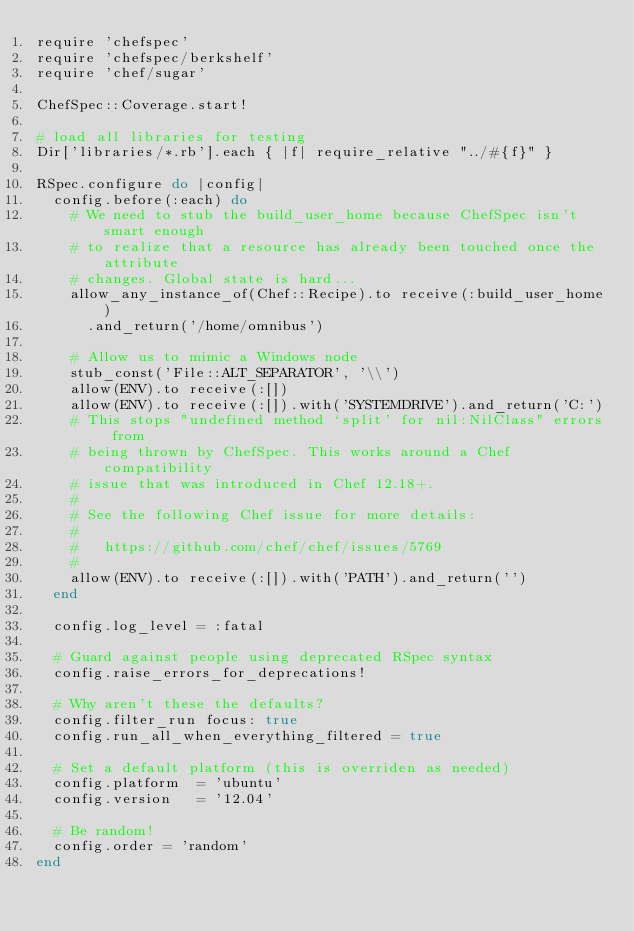Convert code to text. <code><loc_0><loc_0><loc_500><loc_500><_Ruby_>require 'chefspec'
require 'chefspec/berkshelf'
require 'chef/sugar'

ChefSpec::Coverage.start!

# load all libraries for testing
Dir['libraries/*.rb'].each { |f| require_relative "../#{f}" }

RSpec.configure do |config|
  config.before(:each) do
    # We need to stub the build_user_home because ChefSpec isn't smart enough
    # to realize that a resource has already been touched once the attribute
    # changes. Global state is hard...
    allow_any_instance_of(Chef::Recipe).to receive(:build_user_home)
      .and_return('/home/omnibus')

    # Allow us to mimic a Windows node
    stub_const('File::ALT_SEPARATOR', '\\')
    allow(ENV).to receive(:[])
    allow(ENV).to receive(:[]).with('SYSTEMDRIVE').and_return('C:')
    # This stops "undefined method `split' for nil:NilClass" errors from
    # being thrown by ChefSpec. This works around a Chef compatibility
    # issue that was introduced in Chef 12.18+.
    #
    # See the following Chef issue for more details:
    #
    #   https://github.com/chef/chef/issues/5769
    #
    allow(ENV).to receive(:[]).with('PATH').and_return('')
  end

  config.log_level = :fatal

  # Guard against people using deprecated RSpec syntax
  config.raise_errors_for_deprecations!

  # Why aren't these the defaults?
  config.filter_run focus: true
  config.run_all_when_everything_filtered = true

  # Set a default platform (this is overriden as needed)
  config.platform  = 'ubuntu'
  config.version   = '12.04'

  # Be random!
  config.order = 'random'
end
</code> 